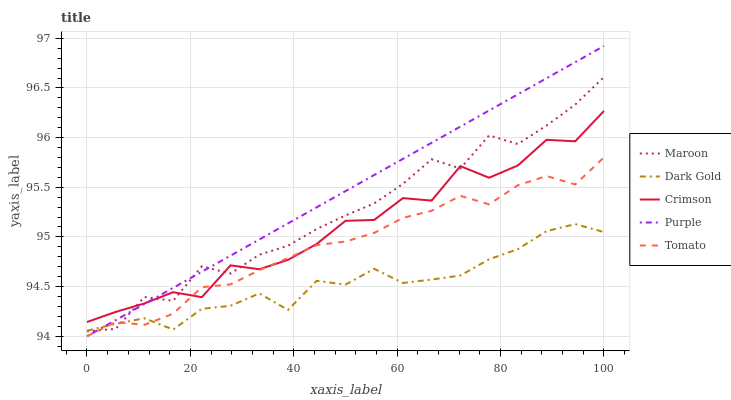Does Dark Gold have the minimum area under the curve?
Answer yes or no. Yes. Does Purple have the maximum area under the curve?
Answer yes or no. Yes. Does Tomato have the minimum area under the curve?
Answer yes or no. No. Does Tomato have the maximum area under the curve?
Answer yes or no. No. Is Purple the smoothest?
Answer yes or no. Yes. Is Crimson the roughest?
Answer yes or no. Yes. Is Tomato the smoothest?
Answer yes or no. No. Is Tomato the roughest?
Answer yes or no. No. Does Purple have the lowest value?
Answer yes or no. Yes. Does Maroon have the lowest value?
Answer yes or no. No. Does Purple have the highest value?
Answer yes or no. Yes. Does Tomato have the highest value?
Answer yes or no. No. Is Dark Gold less than Crimson?
Answer yes or no. Yes. Is Crimson greater than Dark Gold?
Answer yes or no. Yes. Does Tomato intersect Maroon?
Answer yes or no. Yes. Is Tomato less than Maroon?
Answer yes or no. No. Is Tomato greater than Maroon?
Answer yes or no. No. Does Dark Gold intersect Crimson?
Answer yes or no. No. 